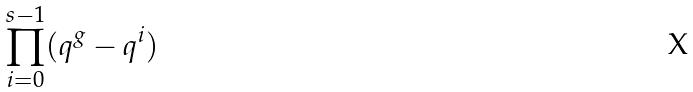<formula> <loc_0><loc_0><loc_500><loc_500>\prod _ { i = 0 } ^ { s - 1 } ( q ^ { g } - q ^ { i } )</formula> 